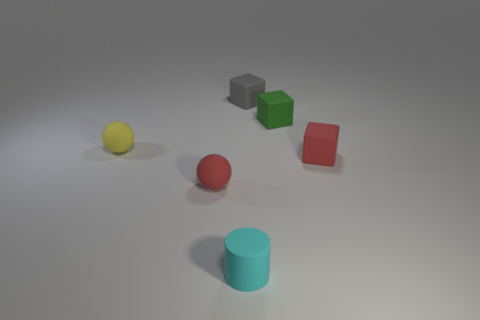What number of other rubber things are the same shape as the tiny gray object?
Make the answer very short. 2. Is the tiny yellow sphere made of the same material as the green thing?
Keep it short and to the point. Yes. What number of red metal spheres are there?
Keep it short and to the point. 0. There is a rubber thing that is on the left side of the tiny red matte object that is on the left side of the red rubber object behind the red ball; what is its color?
Provide a short and direct response. Yellow. How many tiny things are behind the red matte sphere and left of the tiny cyan cylinder?
Provide a short and direct response. 1. How many rubber things are tiny gray cubes or tiny cyan cylinders?
Provide a succinct answer. 2. There is a cyan rubber object that is the same size as the green rubber cube; what shape is it?
Give a very brief answer. Cylinder. Is the number of large brown metallic cylinders less than the number of tiny green blocks?
Provide a succinct answer. Yes. Are there any tiny red rubber blocks that are behind the tiny red matte object on the right side of the gray rubber block?
Make the answer very short. No. What is the shape of the small yellow object that is made of the same material as the small cylinder?
Your response must be concise. Sphere. 